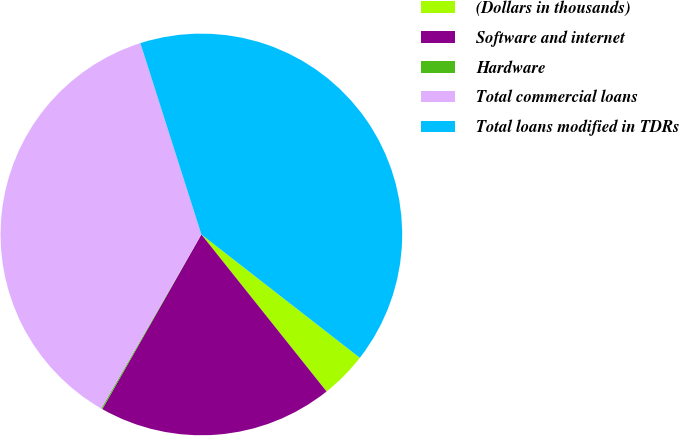<chart> <loc_0><loc_0><loc_500><loc_500><pie_chart><fcel>(Dollars in thousands)<fcel>Software and internet<fcel>Hardware<fcel>Total commercial loans<fcel>Total loans modified in TDRs<nl><fcel>3.76%<fcel>18.92%<fcel>0.1%<fcel>36.78%<fcel>40.44%<nl></chart> 